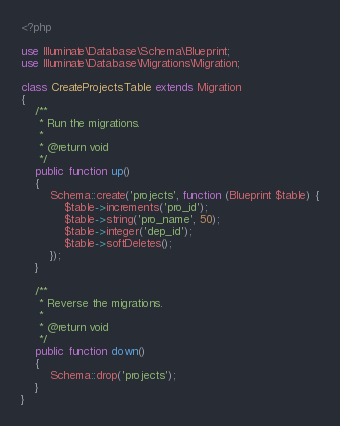<code> <loc_0><loc_0><loc_500><loc_500><_PHP_><?php

use Illuminate\Database\Schema\Blueprint;
use Illuminate\Database\Migrations\Migration;

class CreateProjectsTable extends Migration
{
    /**
     * Run the migrations.
     *
     * @return void
     */
    public function up()
    {
        Schema::create('projects', function (Blueprint $table) {
            $table->increments('pro_id');
            $table->string('pro_name', 50);
            $table->integer('dep_id');
            $table->softDeletes();
        });
    }

    /**
     * Reverse the migrations.
     *
     * @return void
     */
    public function down()
    {
        Schema::drop('projects');
    }
}
</code> 